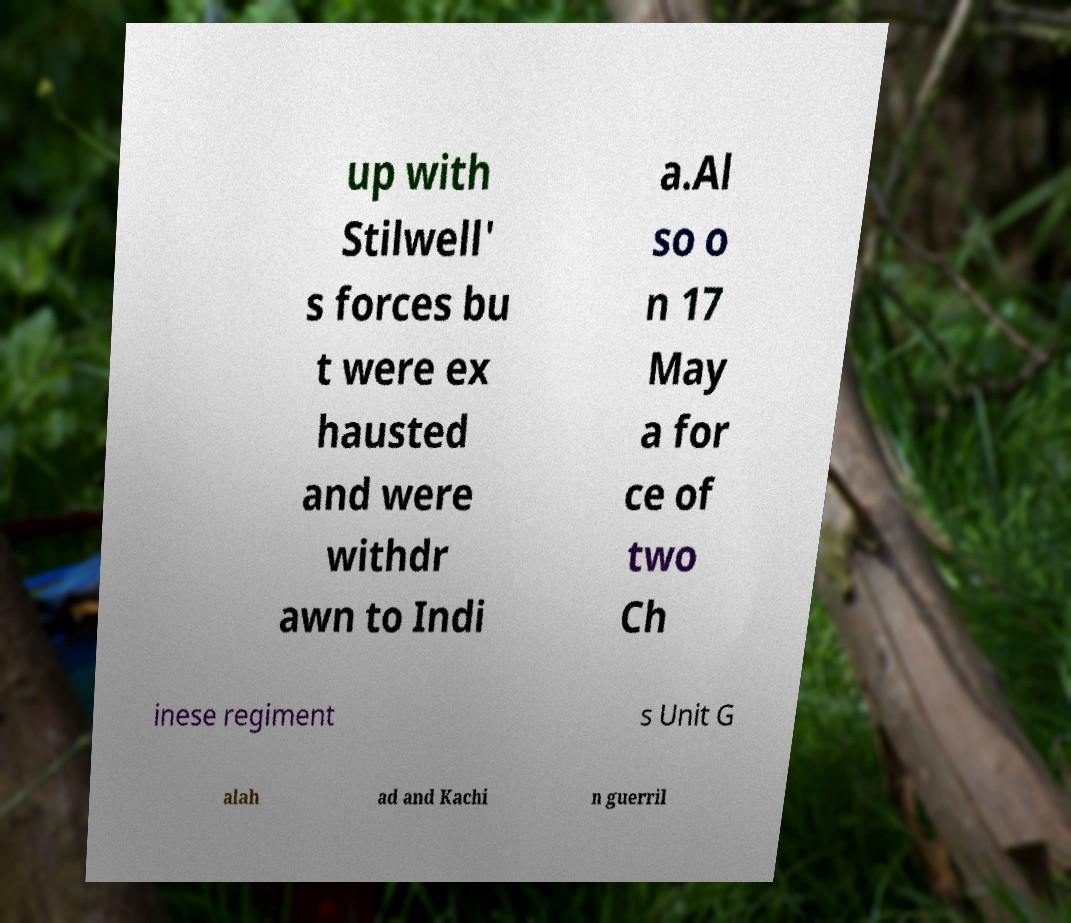Can you accurately transcribe the text from the provided image for me? up with Stilwell' s forces bu t were ex hausted and were withdr awn to Indi a.Al so o n 17 May a for ce of two Ch inese regiment s Unit G alah ad and Kachi n guerril 